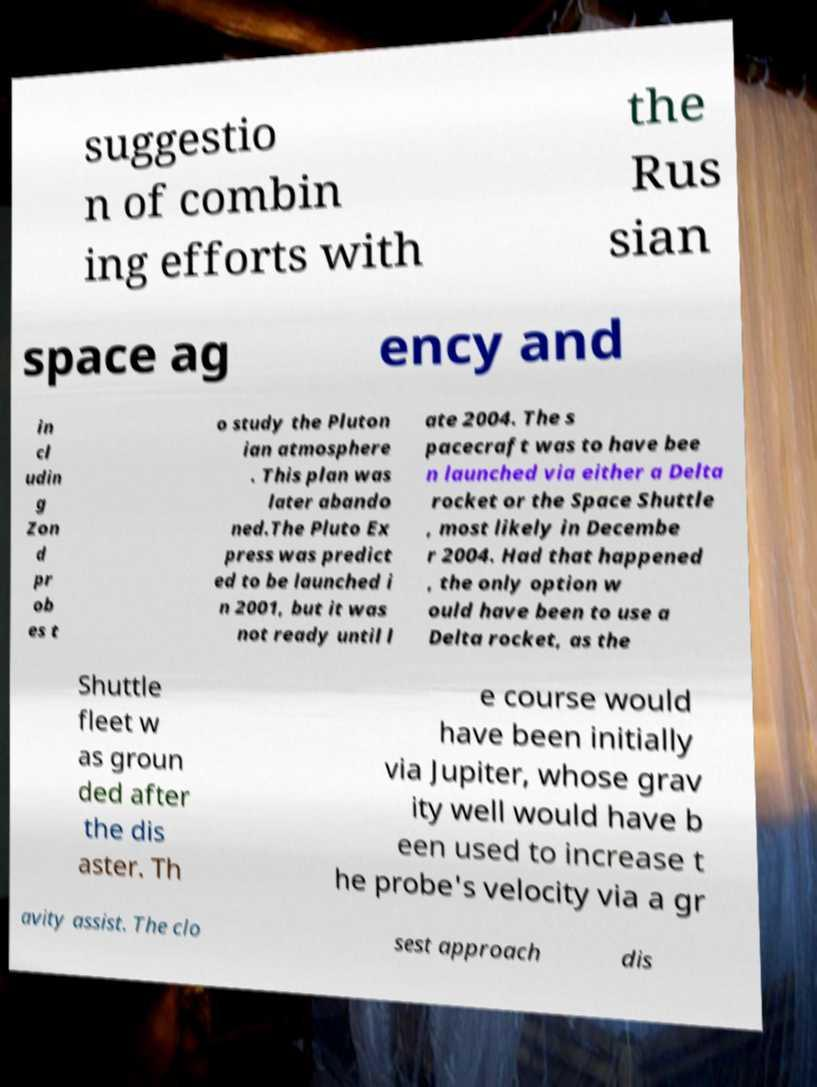What messages or text are displayed in this image? I need them in a readable, typed format. suggestio n of combin ing efforts with the Rus sian space ag ency and in cl udin g Zon d pr ob es t o study the Pluton ian atmosphere . This plan was later abando ned.The Pluto Ex press was predict ed to be launched i n 2001, but it was not ready until l ate 2004. The s pacecraft was to have bee n launched via either a Delta rocket or the Space Shuttle , most likely in Decembe r 2004. Had that happened , the only option w ould have been to use a Delta rocket, as the Shuttle fleet w as groun ded after the dis aster. Th e course would have been initially via Jupiter, whose grav ity well would have b een used to increase t he probe's velocity via a gr avity assist. The clo sest approach dis 